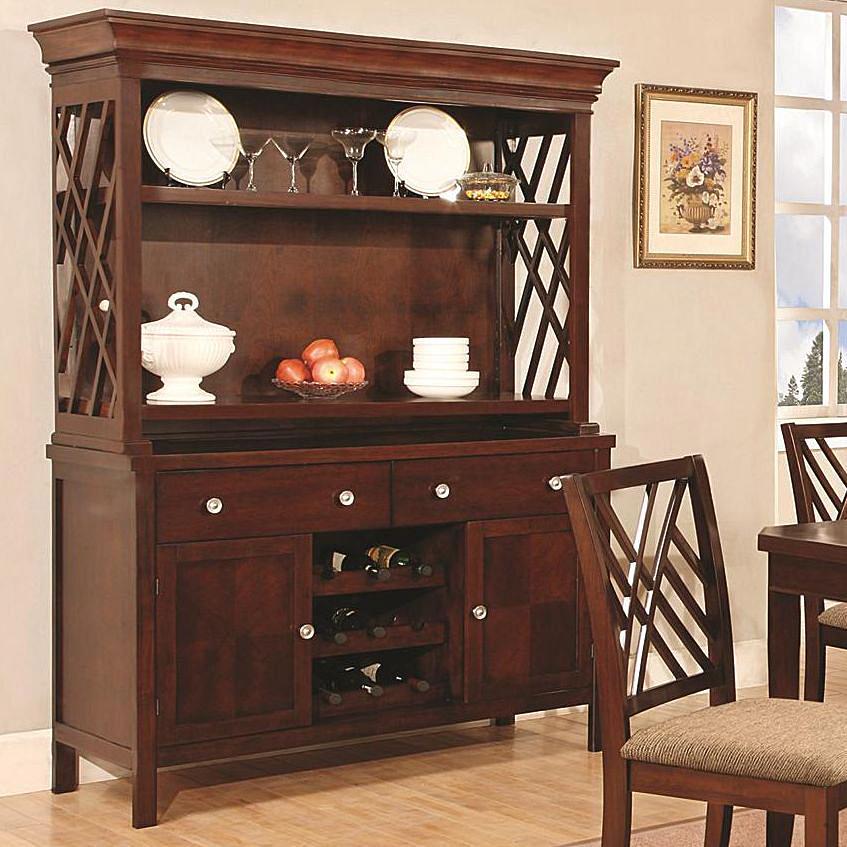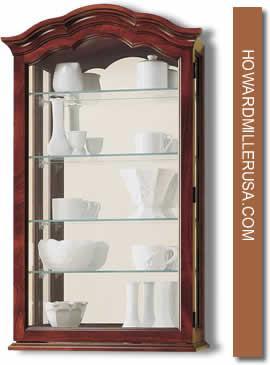The first image is the image on the left, the second image is the image on the right. Assess this claim about the two images: "A large china cupboard unit in one image is built flush with the wall, with solid doors at the bottom and glass doors at the top.". Correct or not? Answer yes or no. No. The first image is the image on the left, the second image is the image on the right. Evaluate the accuracy of this statement regarding the images: "One image shows a bright white cabinet with a flat top.". Is it true? Answer yes or no. No. 